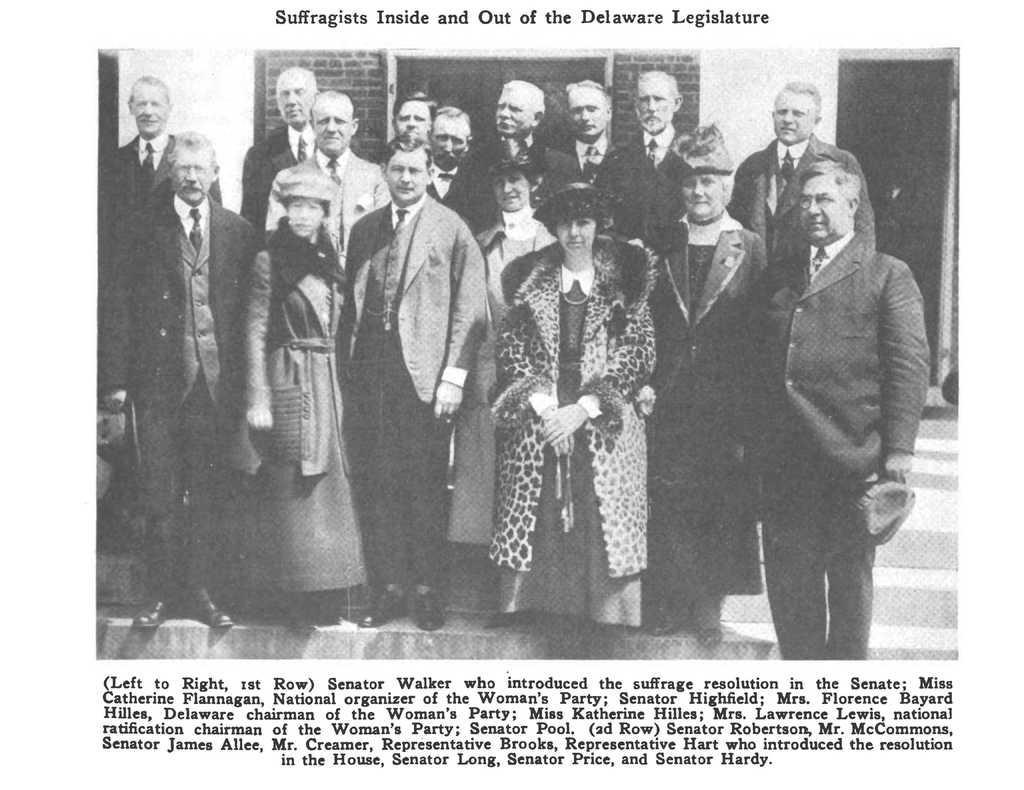How would you summarize this image in a sentence or two? In this image, we can see an article. Here we can see a picture. In this picture, we can see a group of people are standing on the stairs. Background we can see brick wall. 